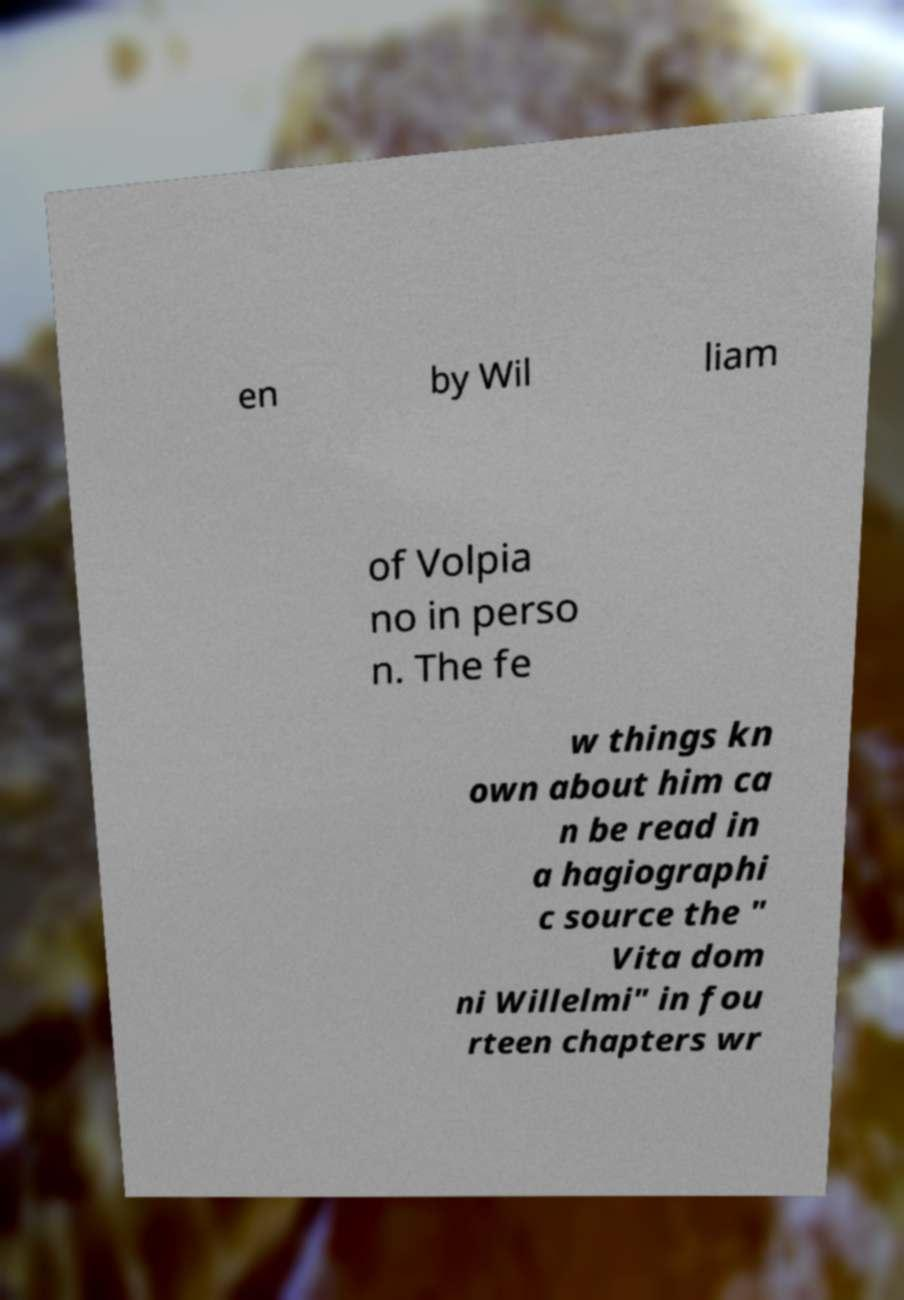I need the written content from this picture converted into text. Can you do that? en by Wil liam of Volpia no in perso n. The fe w things kn own about him ca n be read in a hagiographi c source the " Vita dom ni Willelmi" in fou rteen chapters wr 